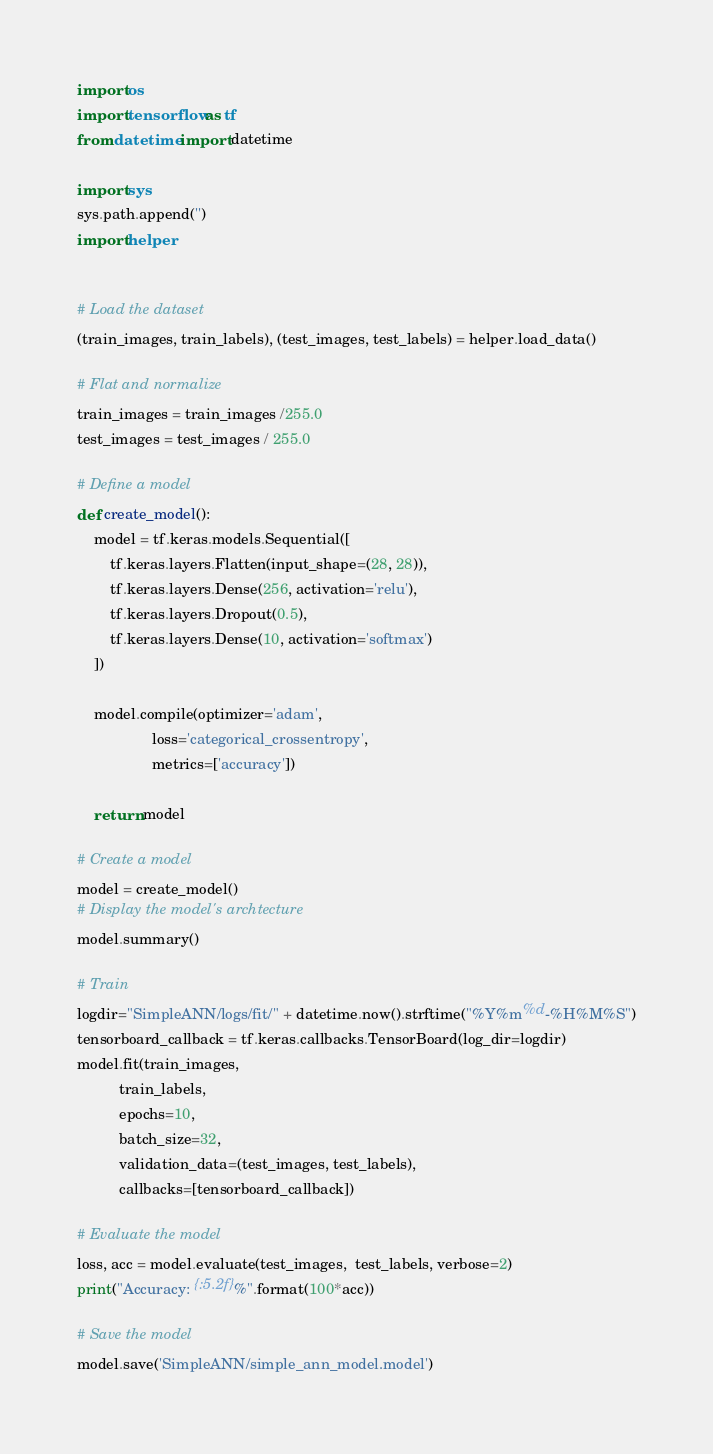Convert code to text. <code><loc_0><loc_0><loc_500><loc_500><_Python_>import os
import tensorflow as tf
from datetime import datetime

import sys
sys.path.append('')
import helper


# Load the dataset
(train_images, train_labels), (test_images, test_labels) = helper.load_data()

# Flat and normalize
train_images = train_images /255.0
test_images = test_images / 255.0

# Define a model
def create_model():
    model = tf.keras.models.Sequential([
        tf.keras.layers.Flatten(input_shape=(28, 28)),
        tf.keras.layers.Dense(256, activation='relu'),
        tf.keras.layers.Dropout(0.5),
        tf.keras.layers.Dense(10, activation='softmax')
    ])

    model.compile(optimizer='adam',
                  loss='categorical_crossentropy',
                  metrics=['accuracy'])
    
    return model

# Create a model
model = create_model()
# Display the model's archtecture
model.summary()

# Train
logdir="SimpleANN/logs/fit/" + datetime.now().strftime("%Y%m%d-%H%M%S")
tensorboard_callback = tf.keras.callbacks.TensorBoard(log_dir=logdir)
model.fit(train_images,
          train_labels,
          epochs=10,
          batch_size=32,
          validation_data=(test_images, test_labels),
          callbacks=[tensorboard_callback])

# Evaluate the model
loss, acc = model.evaluate(test_images,  test_labels, verbose=2)
print("Accuracy: {:5.2f}%".format(100*acc))

# Save the model
model.save('SimpleANN/simple_ann_model.model')

</code> 